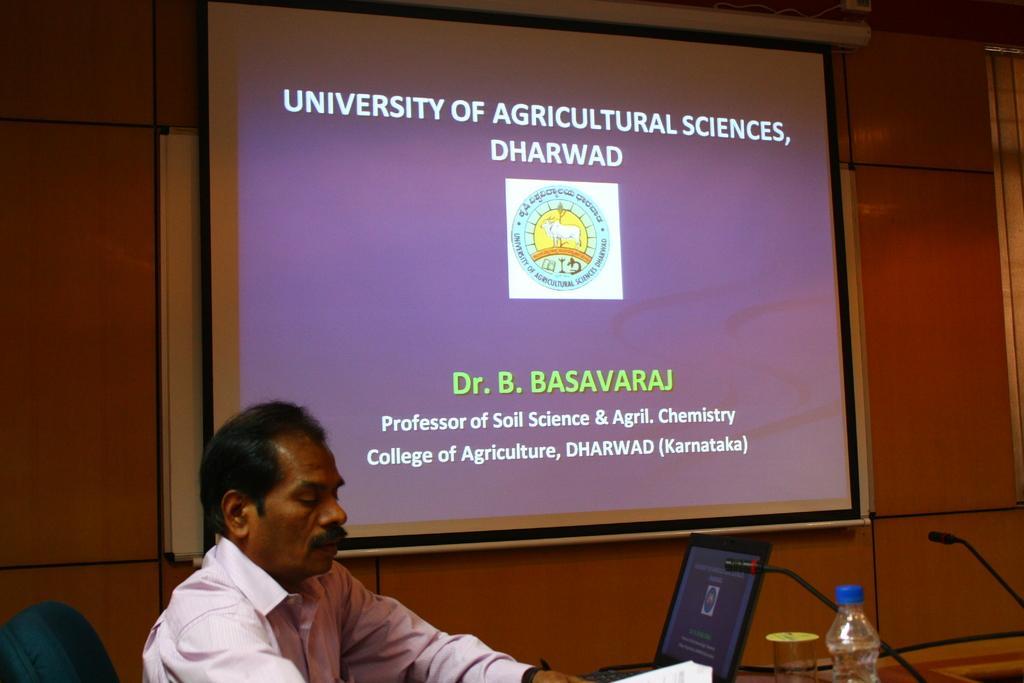<image>
Share a concise interpretation of the image provided. Man sitting at a desk as if he is conducting a meeting with a screen that states University of Agricultural Science Dharwad Dr. B Basavaraj. 